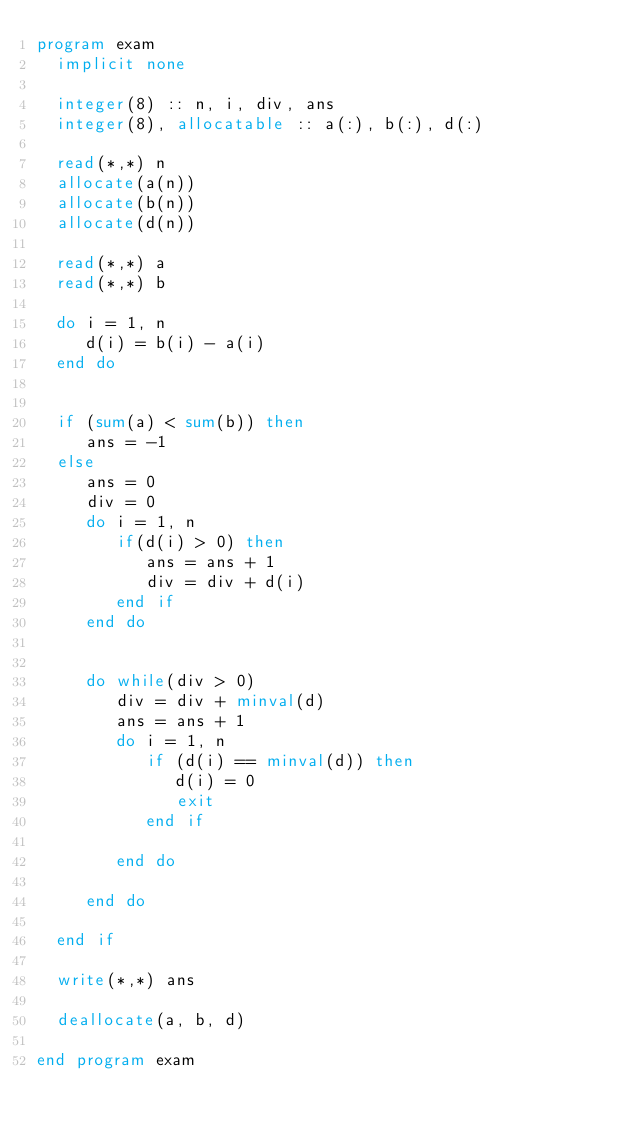Convert code to text. <code><loc_0><loc_0><loc_500><loc_500><_FORTRAN_>program exam
  implicit none

  integer(8) :: n, i, div, ans
  integer(8), allocatable :: a(:), b(:), d(:)

  read(*,*) n
  allocate(a(n))
  allocate(b(n))
  allocate(d(n))

  read(*,*) a
  read(*,*) b

  do i = 1, n
     d(i) = b(i) - a(i)
  end do

  
  if (sum(a) < sum(b)) then
     ans = -1
  else
     ans = 0
     div = 0
     do i = 1, n
        if(d(i) > 0) then
           ans = ans + 1
           div = div + d(i)
        end if
     end do

     
     do while(div > 0)
        div = div + minval(d)
        ans = ans + 1
        do i = 1, n
           if (d(i) == minval(d)) then
              d(i) = 0
              exit
           end if

        end do

     end do

  end if

  write(*,*) ans

  deallocate(a, b, d)

end program exam


           
        
</code> 